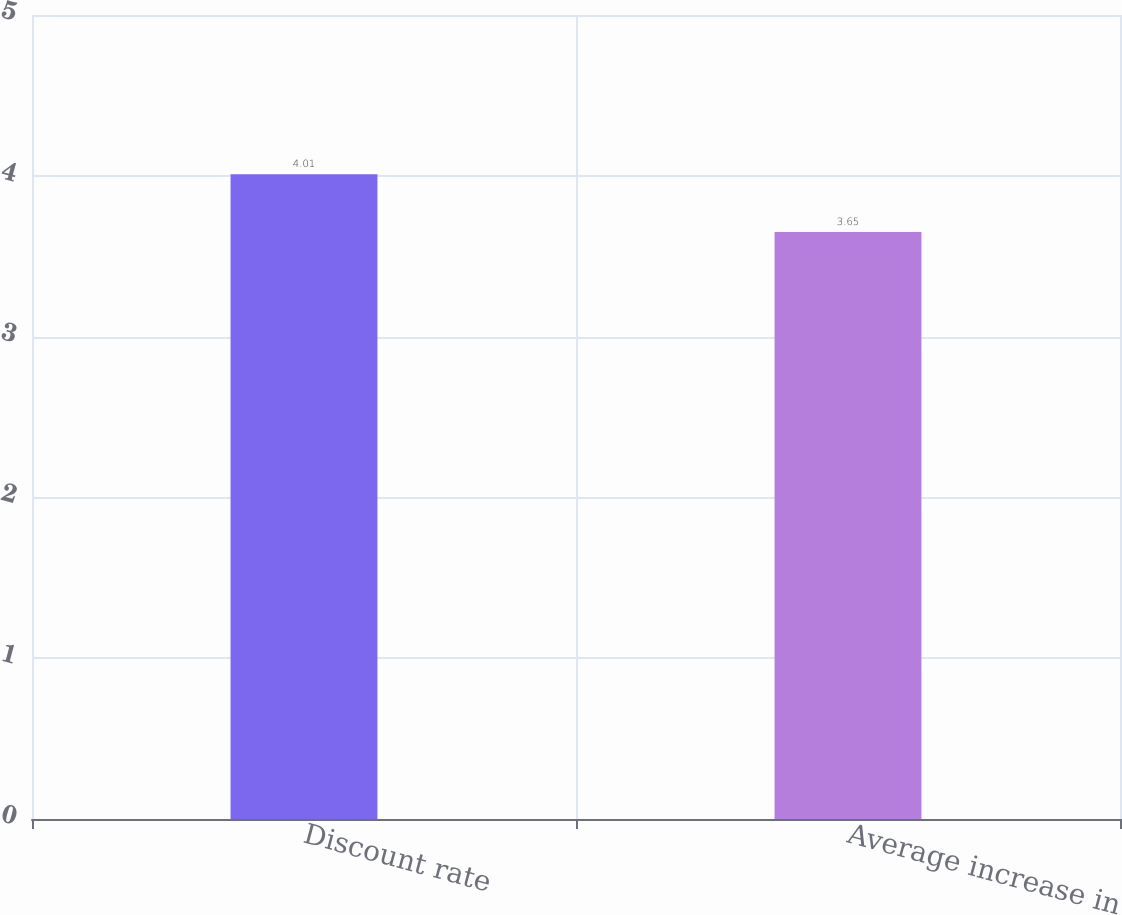Convert chart. <chart><loc_0><loc_0><loc_500><loc_500><bar_chart><fcel>Discount rate<fcel>Average increase in<nl><fcel>4.01<fcel>3.65<nl></chart> 